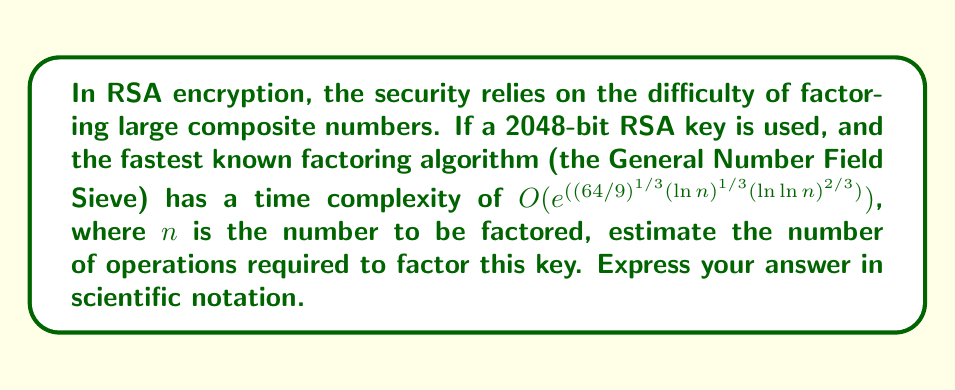Can you solve this math problem? To solve this problem, we'll follow these steps:

1) A 2048-bit RSA key means $n$ is approximately $2^{2048}$.

2) The time complexity is given by:
   $$O(e^{((64/9)^{1/3}(\ln n)^{1/3}(\ln \ln n)^{2/3})})$$

3) Let's substitute $n = 2^{2048}$:
   $$\ln n = \ln(2^{2048}) = 2048 \ln 2$$
   $$\ln \ln n = \ln(2048 \ln 2) \approx 7.6$$

4) Now, let's calculate the exponent:
   $$(64/9)^{1/3} \approx 1.92$$
   $$(\ln n)^{1/3} = (2048 \ln 2)^{1/3} \approx 9.23$$
   $$(\ln \ln n)^{2/3} \approx 4.16$$

5) Multiplying these terms:
   $$1.92 \times 9.23 \times 4.16 \approx 73.8$$

6) Therefore, the number of operations is approximately:
   $$e^{73.8} \approx 1.05 \times 10^{32}$$

This is an enormous number, demonstrating why RSA with large keys is considered secure against factoring attacks.
Answer: $1.05 \times 10^{32}$ operations 